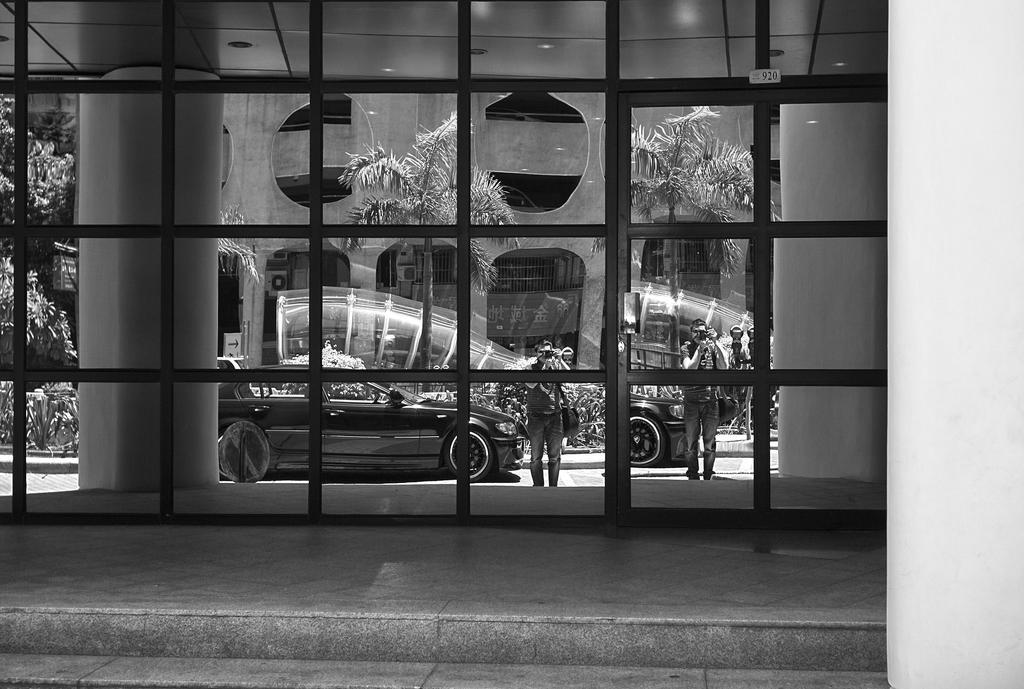Describe this image in one or two sentences. In this image I can see a glass door with grilles, other side I can see some vehicles, persons holding cameras, trees, buildings. 